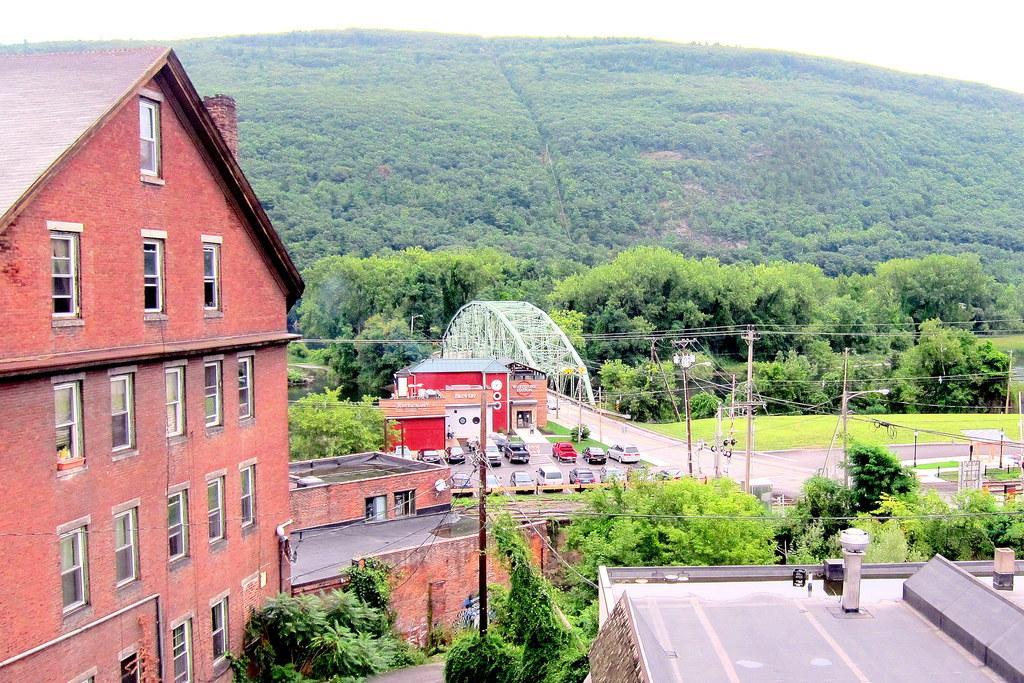Describe this image in one or two sentences. In the center of the image we can see a bridge, cars, buildings, poles, wires, trees, grass are present. In the background of the image hill is there. In the middle of the image sky is present. In the middle of the image road is there. In the middle of the image water is present. 